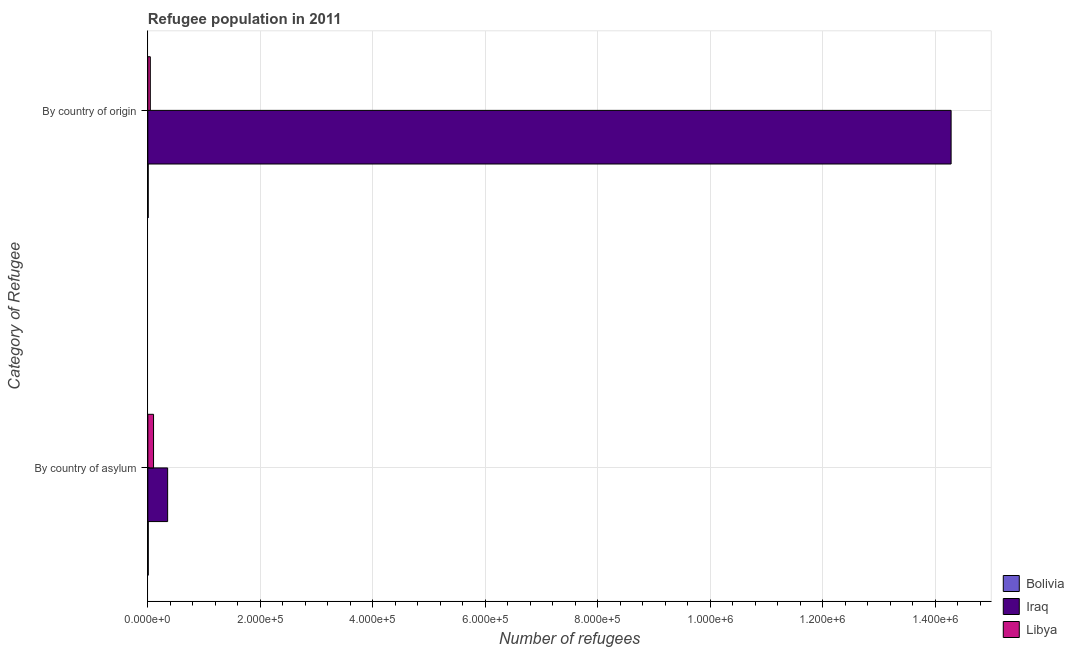How many different coloured bars are there?
Your response must be concise. 3. What is the label of the 2nd group of bars from the top?
Make the answer very short. By country of asylum. What is the number of refugees by country of asylum in Iraq?
Keep it short and to the point. 3.52e+04. Across all countries, what is the maximum number of refugees by country of asylum?
Provide a succinct answer. 3.52e+04. Across all countries, what is the minimum number of refugees by country of origin?
Provide a succinct answer. 611. In which country was the number of refugees by country of asylum maximum?
Provide a succinct answer. Iraq. In which country was the number of refugees by country of asylum minimum?
Make the answer very short. Bolivia. What is the total number of refugees by country of asylum in the graph?
Give a very brief answer. 4.60e+04. What is the difference between the number of refugees by country of origin in Bolivia and that in Iraq?
Provide a short and direct response. -1.43e+06. What is the difference between the number of refugees by country of asylum in Iraq and the number of refugees by country of origin in Libya?
Your answer should be very brief. 3.08e+04. What is the average number of refugees by country of origin per country?
Offer a very short reply. 4.78e+05. What is the difference between the number of refugees by country of origin and number of refugees by country of asylum in Libya?
Provide a succinct answer. -5746. What is the ratio of the number of refugees by country of asylum in Libya to that in Iraq?
Keep it short and to the point. 0.29. In how many countries, is the number of refugees by country of origin greater than the average number of refugees by country of origin taken over all countries?
Provide a short and direct response. 1. What does the 1st bar from the bottom in By country of origin represents?
Provide a short and direct response. Bolivia. How many bars are there?
Provide a succinct answer. 6. Are all the bars in the graph horizontal?
Provide a short and direct response. Yes. How many countries are there in the graph?
Provide a succinct answer. 3. What is the difference between two consecutive major ticks on the X-axis?
Your answer should be very brief. 2.00e+05. Are the values on the major ticks of X-axis written in scientific E-notation?
Give a very brief answer. Yes. Does the graph contain grids?
Provide a succinct answer. Yes. How many legend labels are there?
Provide a succinct answer. 3. How are the legend labels stacked?
Give a very brief answer. Vertical. What is the title of the graph?
Offer a terse response. Refugee population in 2011. What is the label or title of the X-axis?
Provide a short and direct response. Number of refugees. What is the label or title of the Y-axis?
Your response must be concise. Category of Refugee. What is the Number of refugees in Bolivia in By country of asylum?
Your answer should be very brief. 716. What is the Number of refugees of Iraq in By country of asylum?
Ensure brevity in your answer.  3.52e+04. What is the Number of refugees in Libya in By country of asylum?
Offer a very short reply. 1.01e+04. What is the Number of refugees of Bolivia in By country of origin?
Provide a short and direct response. 611. What is the Number of refugees of Iraq in By country of origin?
Provide a short and direct response. 1.43e+06. What is the Number of refugees in Libya in By country of origin?
Your response must be concise. 4384. Across all Category of Refugee, what is the maximum Number of refugees of Bolivia?
Offer a very short reply. 716. Across all Category of Refugee, what is the maximum Number of refugees of Iraq?
Provide a succinct answer. 1.43e+06. Across all Category of Refugee, what is the maximum Number of refugees of Libya?
Offer a terse response. 1.01e+04. Across all Category of Refugee, what is the minimum Number of refugees of Bolivia?
Give a very brief answer. 611. Across all Category of Refugee, what is the minimum Number of refugees in Iraq?
Provide a short and direct response. 3.52e+04. Across all Category of Refugee, what is the minimum Number of refugees of Libya?
Provide a short and direct response. 4384. What is the total Number of refugees in Bolivia in the graph?
Keep it short and to the point. 1327. What is the total Number of refugees in Iraq in the graph?
Provide a succinct answer. 1.46e+06. What is the total Number of refugees of Libya in the graph?
Ensure brevity in your answer.  1.45e+04. What is the difference between the Number of refugees of Bolivia in By country of asylum and that in By country of origin?
Keep it short and to the point. 105. What is the difference between the Number of refugees of Iraq in By country of asylum and that in By country of origin?
Your answer should be very brief. -1.39e+06. What is the difference between the Number of refugees in Libya in By country of asylum and that in By country of origin?
Make the answer very short. 5746. What is the difference between the Number of refugees of Bolivia in By country of asylum and the Number of refugees of Iraq in By country of origin?
Keep it short and to the point. -1.43e+06. What is the difference between the Number of refugees of Bolivia in By country of asylum and the Number of refugees of Libya in By country of origin?
Provide a succinct answer. -3668. What is the difference between the Number of refugees of Iraq in By country of asylum and the Number of refugees of Libya in By country of origin?
Provide a succinct answer. 3.08e+04. What is the average Number of refugees in Bolivia per Category of Refugee?
Your answer should be very brief. 663.5. What is the average Number of refugees of Iraq per Category of Refugee?
Make the answer very short. 7.32e+05. What is the average Number of refugees in Libya per Category of Refugee?
Offer a very short reply. 7257. What is the difference between the Number of refugees in Bolivia and Number of refugees in Iraq in By country of asylum?
Offer a terse response. -3.45e+04. What is the difference between the Number of refugees of Bolivia and Number of refugees of Libya in By country of asylum?
Your response must be concise. -9414. What is the difference between the Number of refugees in Iraq and Number of refugees in Libya in By country of asylum?
Provide a succinct answer. 2.51e+04. What is the difference between the Number of refugees in Bolivia and Number of refugees in Iraq in By country of origin?
Offer a terse response. -1.43e+06. What is the difference between the Number of refugees of Bolivia and Number of refugees of Libya in By country of origin?
Keep it short and to the point. -3773. What is the difference between the Number of refugees of Iraq and Number of refugees of Libya in By country of origin?
Offer a terse response. 1.42e+06. What is the ratio of the Number of refugees of Bolivia in By country of asylum to that in By country of origin?
Keep it short and to the point. 1.17. What is the ratio of the Number of refugees in Iraq in By country of asylum to that in By country of origin?
Your answer should be very brief. 0.02. What is the ratio of the Number of refugees in Libya in By country of asylum to that in By country of origin?
Offer a very short reply. 2.31. What is the difference between the highest and the second highest Number of refugees in Bolivia?
Provide a succinct answer. 105. What is the difference between the highest and the second highest Number of refugees of Iraq?
Your answer should be very brief. 1.39e+06. What is the difference between the highest and the second highest Number of refugees of Libya?
Provide a short and direct response. 5746. What is the difference between the highest and the lowest Number of refugees of Bolivia?
Give a very brief answer. 105. What is the difference between the highest and the lowest Number of refugees of Iraq?
Ensure brevity in your answer.  1.39e+06. What is the difference between the highest and the lowest Number of refugees in Libya?
Ensure brevity in your answer.  5746. 